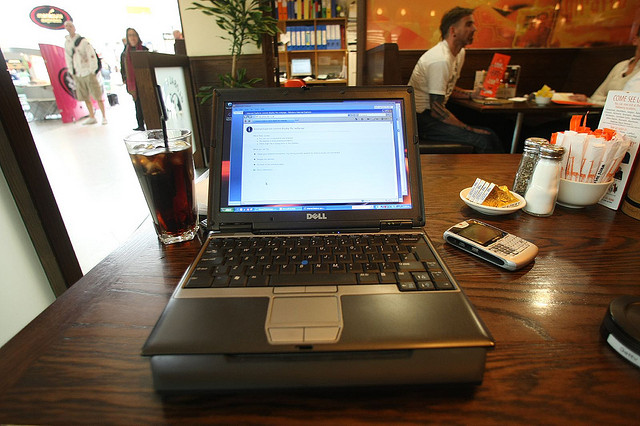Identify and read out the text in this image. DELL 